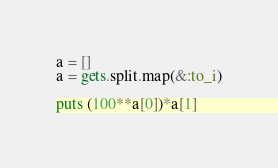<code> <loc_0><loc_0><loc_500><loc_500><_Ruby_>a = []
a = gets.split.map(&:to_i)

puts (100**a[0])*a[1]</code> 